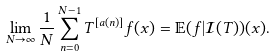<formula> <loc_0><loc_0><loc_500><loc_500>\lim _ { N \to \infty } \frac { 1 } { N } \sum _ { n = 0 } ^ { N - 1 } T ^ { [ a ( n ) ] } f ( x ) = \mathbb { E } ( f | \mathcal { I } ( T ) ) ( x ) .</formula> 